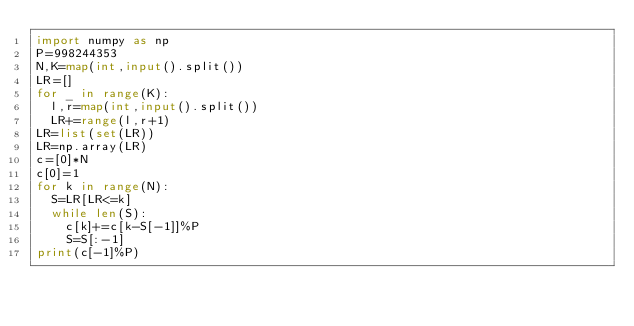Convert code to text. <code><loc_0><loc_0><loc_500><loc_500><_Python_>import numpy as np
P=998244353
N,K=map(int,input().split())
LR=[]
for _ in range(K):
  l,r=map(int,input().split())
  LR+=range(l,r+1)
LR=list(set(LR))
LR=np.array(LR)
c=[0]*N
c[0]=1
for k in range(N):
  S=LR[LR<=k]
  while len(S):
    c[k]+=c[k-S[-1]]%P
    S=S[:-1]
print(c[-1]%P)</code> 